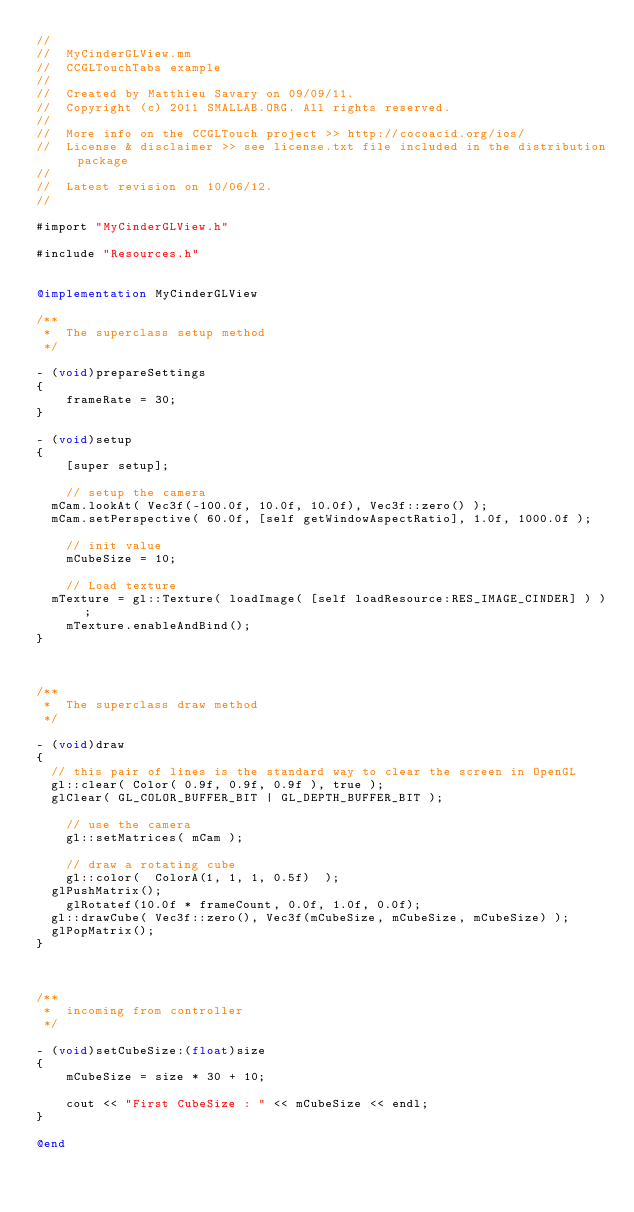Convert code to text. <code><loc_0><loc_0><loc_500><loc_500><_ObjectiveC_>//
//  MyCinderGLView.mm
//  CCGLTouchTabs example
//
//  Created by Matthieu Savary on 09/09/11.
//  Copyright (c) 2011 SMALLAB.ORG. All rights reserved.
//
//  More info on the CCGLTouch project >> http://cocoacid.org/ios/
//  License & disclaimer >> see license.txt file included in the distribution package
//
//  Latest revision on 10/06/12.
//

#import "MyCinderGLView.h"

#include "Resources.h"


@implementation MyCinderGLView

/**
 *	The superclass setup method
 */

- (void)prepareSettings
{
    frameRate = 30;
}

- (void)setup
{
    [super setup];
    
    // setup the camera
	mCam.lookAt( Vec3f(-100.0f, 10.0f, 10.0f), Vec3f::zero() );
	mCam.setPerspective( 60.0f, [self getWindowAspectRatio], 1.0f, 1000.0f );
	
    // init value
    mCubeSize = 10;
    
    // Load texture
	mTexture = gl::Texture( loadImage( [self loadResource:RES_IMAGE_CINDER] ) );
    mTexture.enableAndBind();
}



/**
 *  The superclass draw method
 */

- (void)draw
{
	// this pair of lines is the standard way to clear the screen in OpenGL
	gl::clear( Color( 0.9f, 0.9f, 0.9f ), true );
	glClear( GL_COLOR_BUFFER_BIT | GL_DEPTH_BUFFER_BIT );
    
    // use the camera
    gl::setMatrices( mCam );
    
    // draw a rotating cube
    gl::color(  ColorA(1, 1, 1, 0.5f)  );
	glPushMatrix();
    glRotatef(10.0f * frameCount, 0.0f, 1.0f, 0.0f);
	gl::drawCube( Vec3f::zero(), Vec3f(mCubeSize, mCubeSize, mCubeSize) );
	glPopMatrix();
}



/**
 *  incoming from controller
 */

- (void)setCubeSize:(float)size
{
    mCubeSize = size * 30 + 10;
    
    cout << "First CubeSize : " << mCubeSize << endl;
}

@end
</code> 